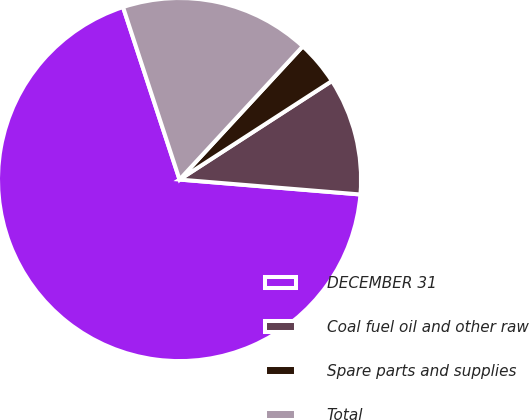Convert chart. <chart><loc_0><loc_0><loc_500><loc_500><pie_chart><fcel>DECEMBER 31<fcel>Coal fuel oil and other raw<fcel>Spare parts and supplies<fcel>Total<nl><fcel>68.65%<fcel>10.45%<fcel>3.98%<fcel>16.92%<nl></chart> 